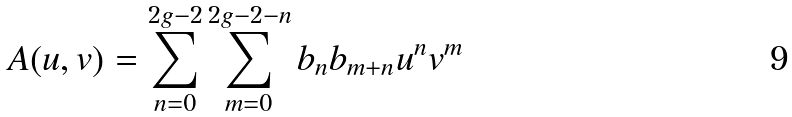Convert formula to latex. <formula><loc_0><loc_0><loc_500><loc_500>A ( u , v ) = \sum _ { n = 0 } ^ { 2 g - 2 } \sum _ { m = 0 } ^ { 2 g - 2 - n } b _ { n } b _ { m + n } u ^ { n } v ^ { m }</formula> 